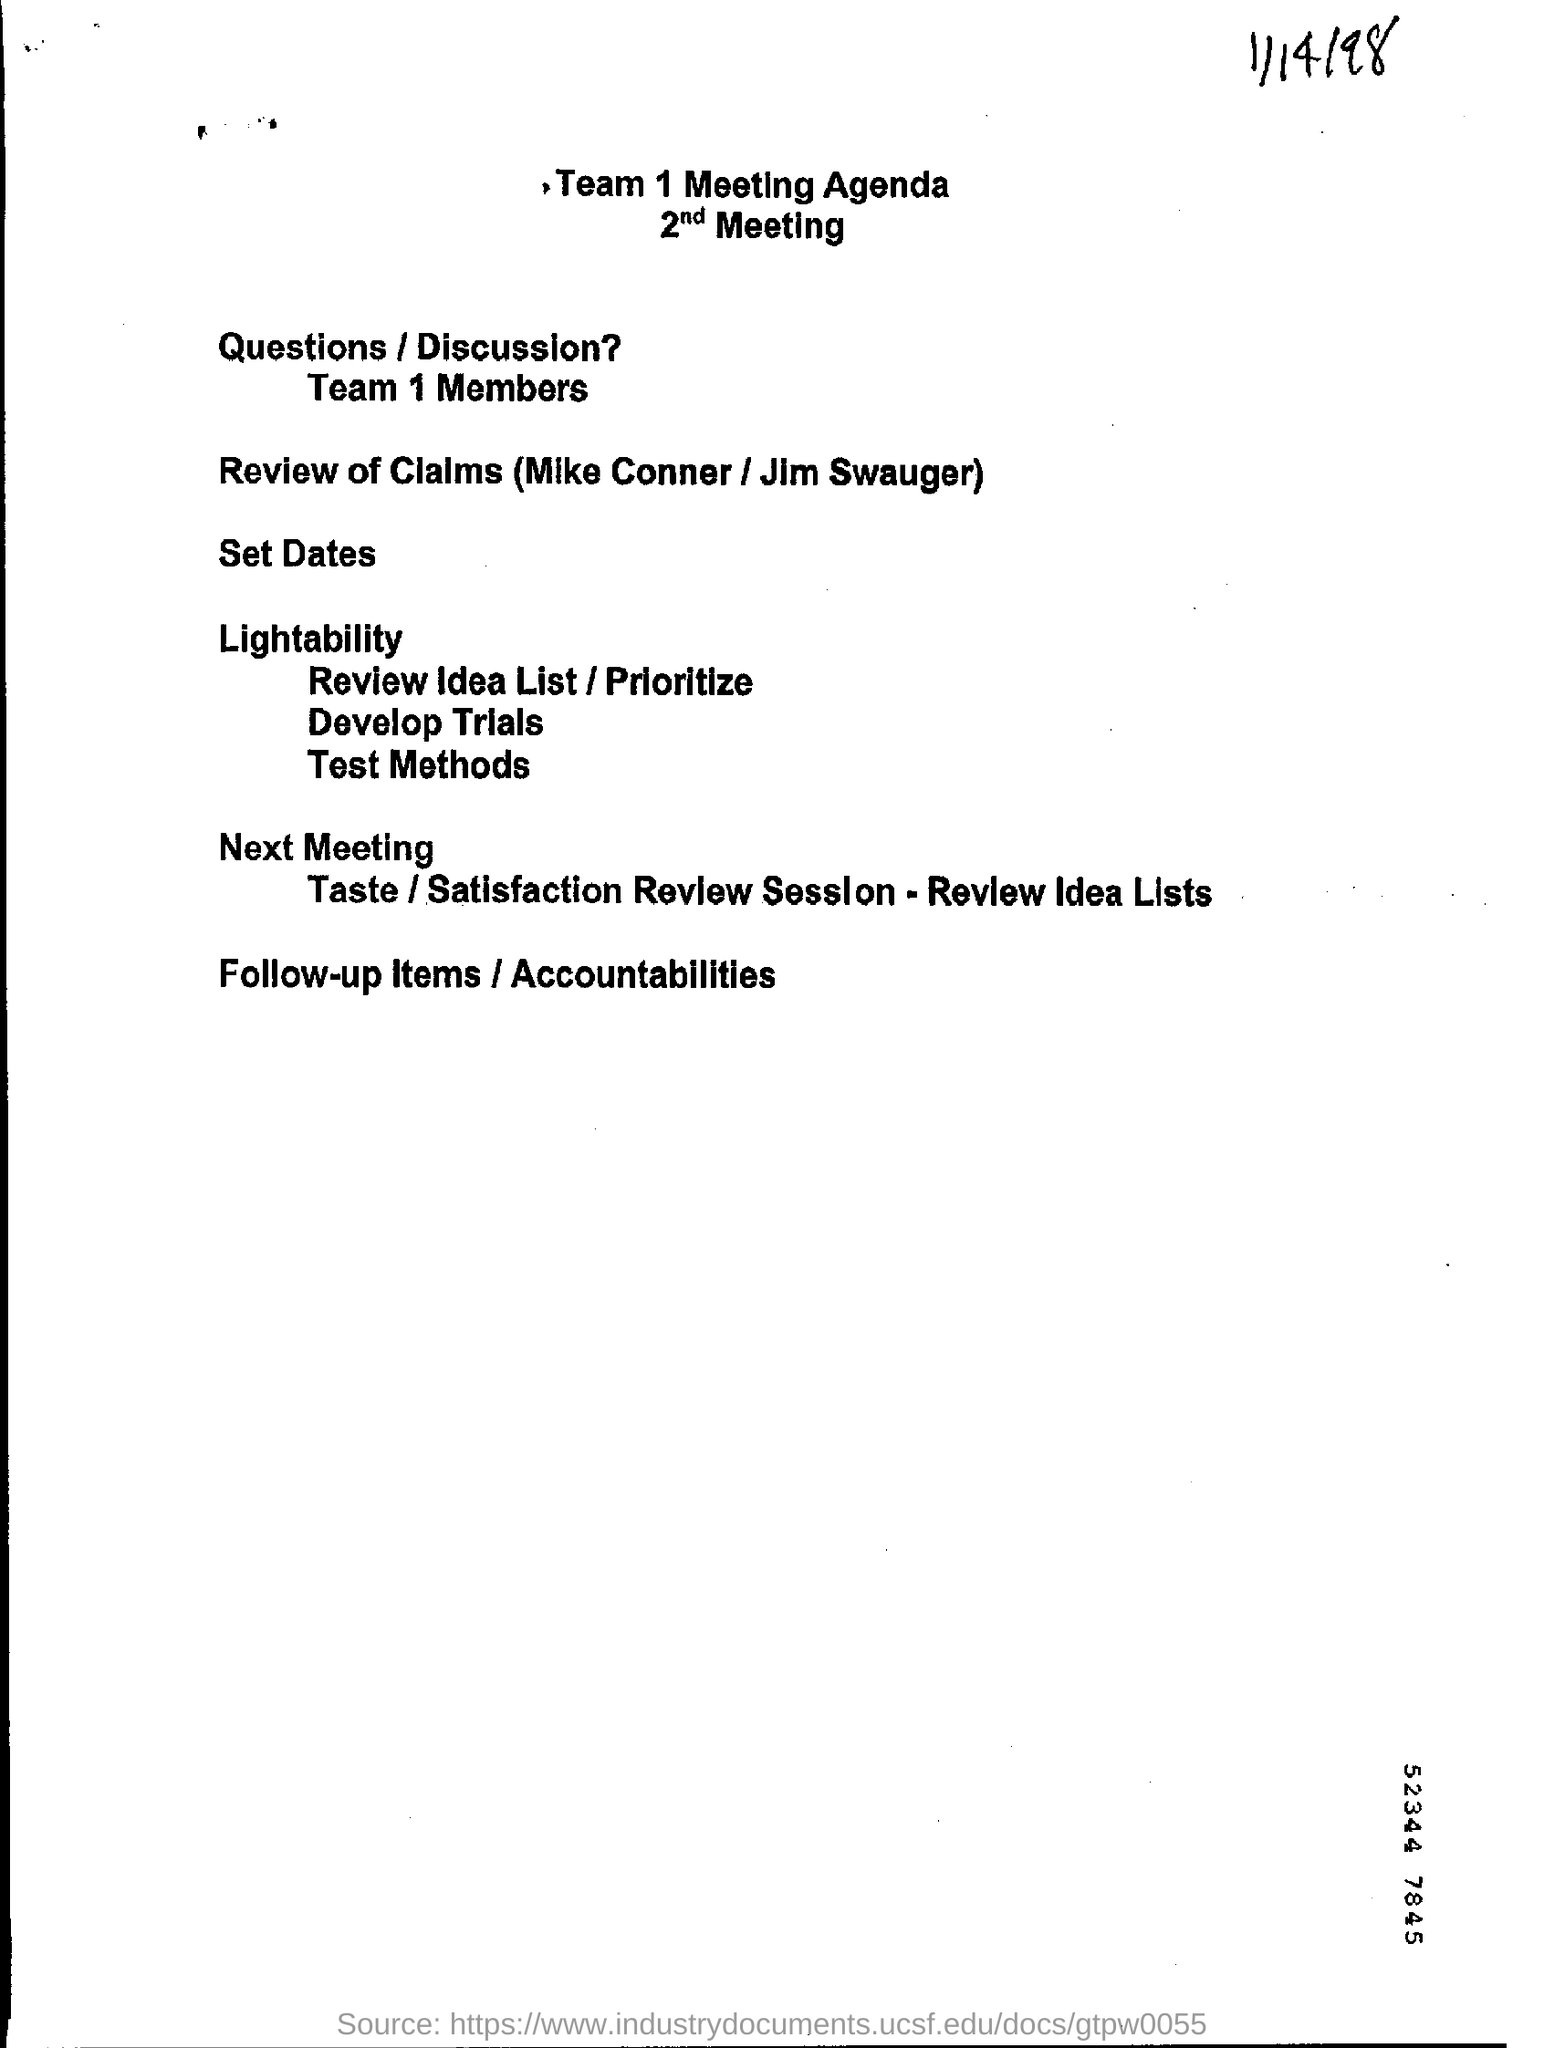Draw attention to some important aspects in this diagram. On the top right corner of the page, mention the date, 1/14/98. 